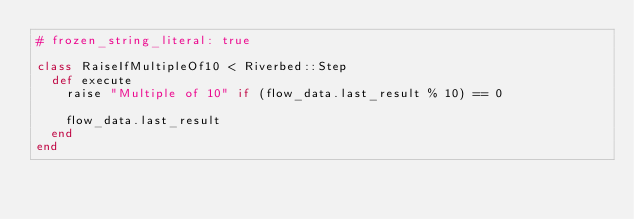Convert code to text. <code><loc_0><loc_0><loc_500><loc_500><_Ruby_># frozen_string_literal: true

class RaiseIfMultipleOf10 < Riverbed::Step
  def execute
    raise "Multiple of 10" if (flow_data.last_result % 10) == 0

    flow_data.last_result
  end
end
</code> 